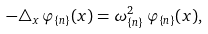Convert formula to latex. <formula><loc_0><loc_0><loc_500><loc_500>- \triangle _ { x } \, \varphi _ { \{ n \} } ( x ) = \omega _ { \{ n \} } ^ { 2 } \, \varphi _ { \{ n \} } ( x ) ,</formula> 